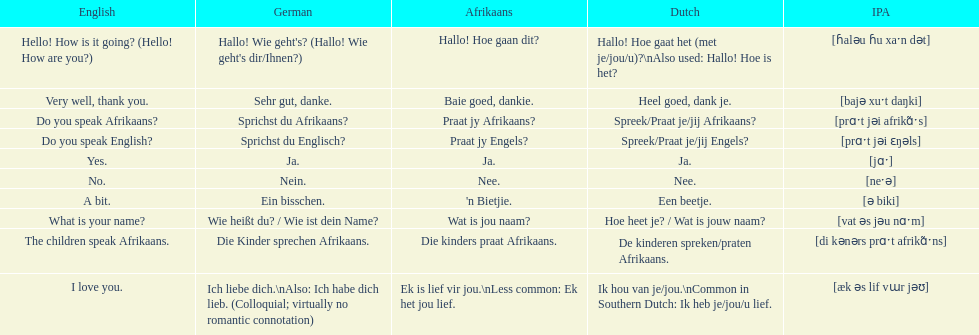How do you say "do you speak afrikaans?" in afrikaans? Praat jy Afrikaans?. 